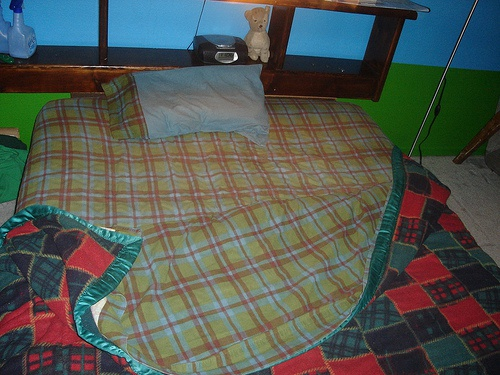Describe the objects in this image and their specific colors. I can see bed in darkblue, gray, and black tones, clock in darkblue, black, gray, blue, and navy tones, teddy bear in darkblue, gray, and black tones, and bottle in darkblue, gray, blue, and navy tones in this image. 